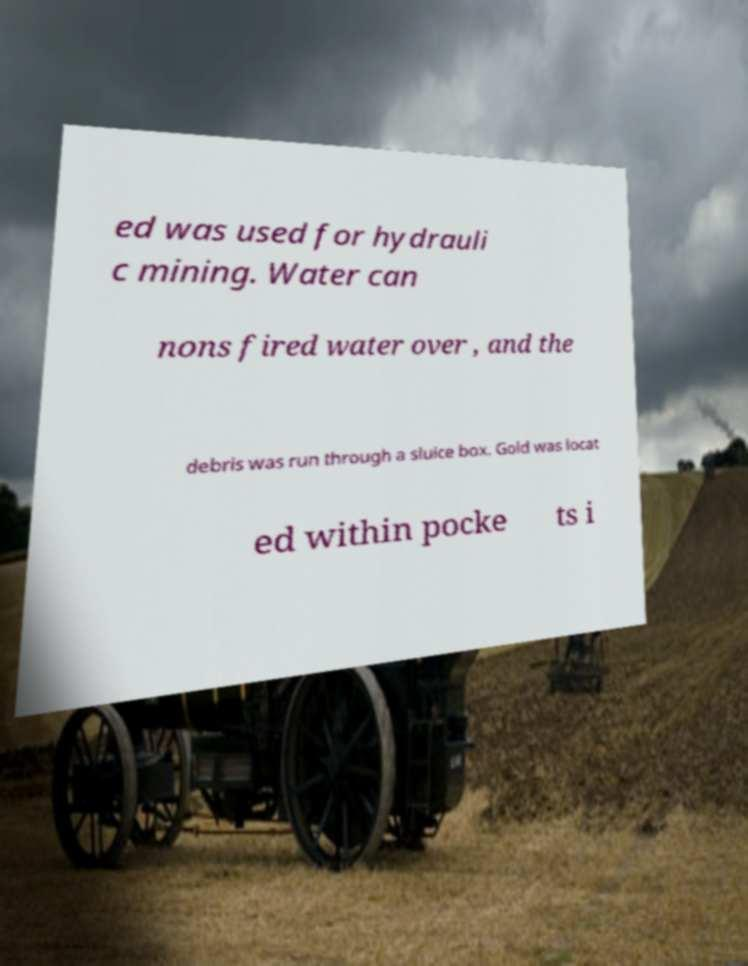Could you extract and type out the text from this image? ed was used for hydrauli c mining. Water can nons fired water over , and the debris was run through a sluice box. Gold was locat ed within pocke ts i 